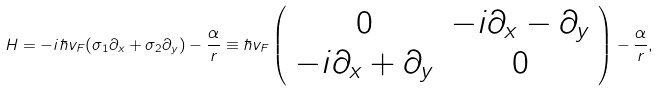Convert formula to latex. <formula><loc_0><loc_0><loc_500><loc_500>H = - i \hbar { v } _ { F } ( { \sigma } _ { 1 } { \partial } _ { x } + { \sigma } _ { 2 } { \partial } _ { y } ) - \frac { \alpha } { r } \equiv \hbar { v } _ { F } \left ( \begin{array} { c c } 0 & - i { \partial } _ { x } - { \partial } _ { y } \\ - i { \partial } _ { x } + { \partial } _ { y } & 0 \\ \end{array} \right ) - \frac { \alpha } { r } ,</formula> 